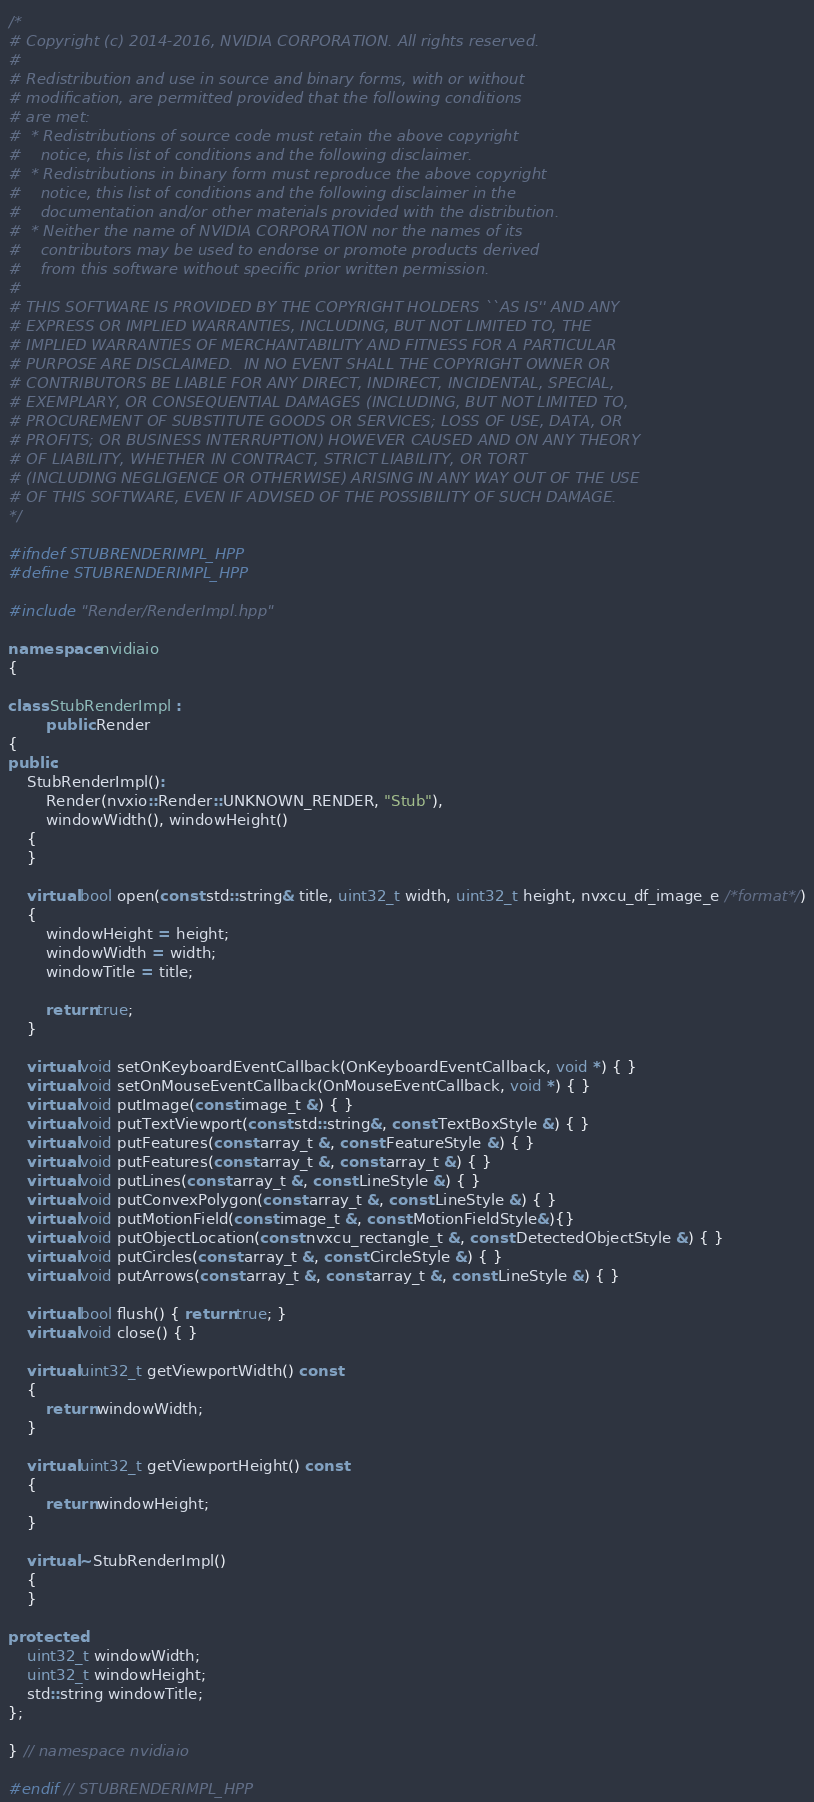Convert code to text. <code><loc_0><loc_0><loc_500><loc_500><_C++_>/*
# Copyright (c) 2014-2016, NVIDIA CORPORATION. All rights reserved.
#
# Redistribution and use in source and binary forms, with or without
# modification, are permitted provided that the following conditions
# are met:
#  * Redistributions of source code must retain the above copyright
#    notice, this list of conditions and the following disclaimer.
#  * Redistributions in binary form must reproduce the above copyright
#    notice, this list of conditions and the following disclaimer in the
#    documentation and/or other materials provided with the distribution.
#  * Neither the name of NVIDIA CORPORATION nor the names of its
#    contributors may be used to endorse or promote products derived
#    from this software without specific prior written permission.
#
# THIS SOFTWARE IS PROVIDED BY THE COPYRIGHT HOLDERS ``AS IS'' AND ANY
# EXPRESS OR IMPLIED WARRANTIES, INCLUDING, BUT NOT LIMITED TO, THE
# IMPLIED WARRANTIES OF MERCHANTABILITY AND FITNESS FOR A PARTICULAR
# PURPOSE ARE DISCLAIMED.  IN NO EVENT SHALL THE COPYRIGHT OWNER OR
# CONTRIBUTORS BE LIABLE FOR ANY DIRECT, INDIRECT, INCIDENTAL, SPECIAL,
# EXEMPLARY, OR CONSEQUENTIAL DAMAGES (INCLUDING, BUT NOT LIMITED TO,
# PROCUREMENT OF SUBSTITUTE GOODS OR SERVICES; LOSS OF USE, DATA, OR
# PROFITS; OR BUSINESS INTERRUPTION) HOWEVER CAUSED AND ON ANY THEORY
# OF LIABILITY, WHETHER IN CONTRACT, STRICT LIABILITY, OR TORT
# (INCLUDING NEGLIGENCE OR OTHERWISE) ARISING IN ANY WAY OUT OF THE USE
# OF THIS SOFTWARE, EVEN IF ADVISED OF THE POSSIBILITY OF SUCH DAMAGE.
*/

#ifndef STUBRENDERIMPL_HPP
#define STUBRENDERIMPL_HPP

#include "Render/RenderImpl.hpp"

namespace nvidiaio
{

class StubRenderImpl :
        public Render
{
public:
    StubRenderImpl():
        Render(nvxio::Render::UNKNOWN_RENDER, "Stub"),
        windowWidth(), windowHeight()
    {
    }

    virtual bool open(const std::string& title, uint32_t width, uint32_t height, nvxcu_df_image_e /*format*/)
    {
        windowHeight = height;
        windowWidth = width;
        windowTitle = title;

        return true;
    }

    virtual void setOnKeyboardEventCallback(OnKeyboardEventCallback, void *) { }
    virtual void setOnMouseEventCallback(OnMouseEventCallback, void *) { }
    virtual void putImage(const image_t &) { }
    virtual void putTextViewport(const std::string&, const TextBoxStyle &) { }
    virtual void putFeatures(const array_t &, const FeatureStyle &) { }
    virtual void putFeatures(const array_t &, const array_t &) { }
    virtual void putLines(const array_t &, const LineStyle &) { }
    virtual void putConvexPolygon(const array_t &, const LineStyle &) { }
    virtual void putMotionField(const image_t &, const MotionFieldStyle&){}
    virtual void putObjectLocation(const nvxcu_rectangle_t &, const DetectedObjectStyle &) { }
    virtual void putCircles(const array_t &, const CircleStyle &) { }
    virtual void putArrows(const array_t &, const array_t &, const LineStyle &) { }

    virtual bool flush() { return true; }
    virtual void close() { }

    virtual uint32_t getViewportWidth() const
    {
        return windowWidth;
    }

    virtual uint32_t getViewportHeight() const
    {
        return windowHeight;
    }

    virtual ~StubRenderImpl()
    {
    }

protected:
    uint32_t windowWidth;
    uint32_t windowHeight;
    std::string windowTitle;
};

} // namespace nvidiaio

#endif // STUBRENDERIMPL_HPP
</code> 